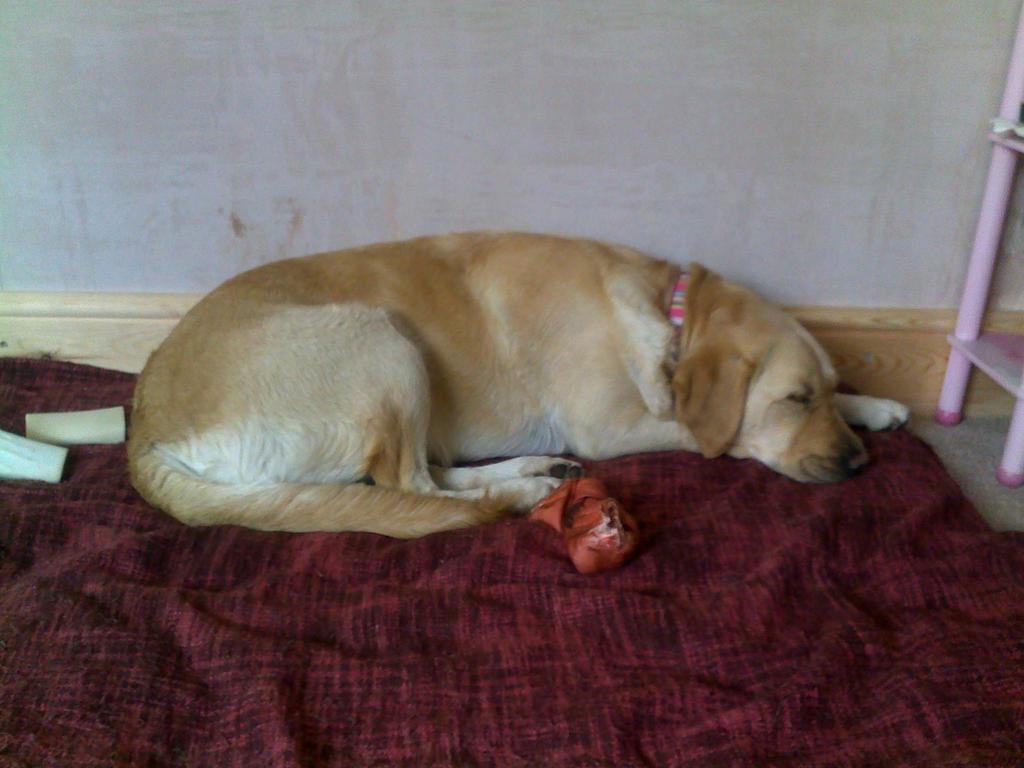How would you summarize this image in a sentence or two? There is a dog lying on the floor. On the floor there is a cloth. Also there is a red color thing. In the back there is a wall. On the right side there is a ladder. 